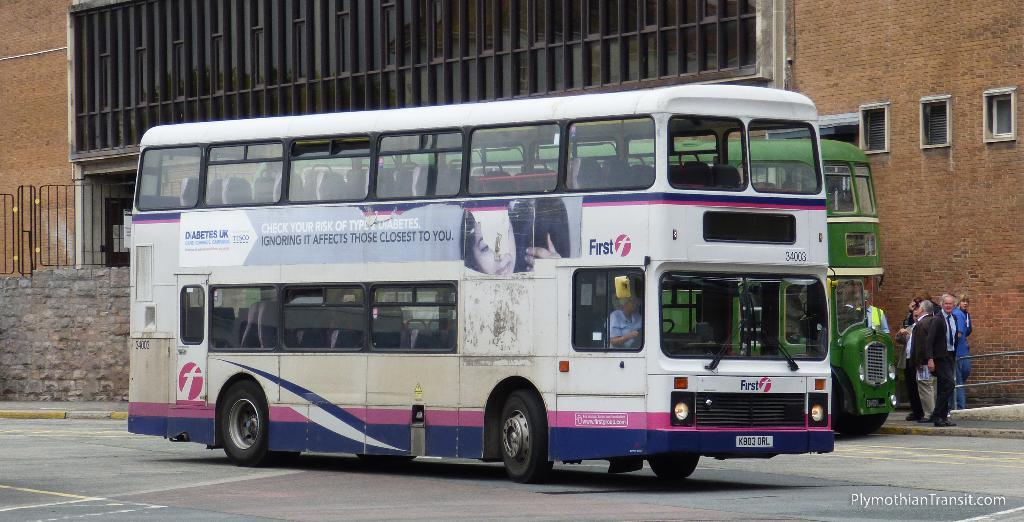<image>
Describe the image concisely. Double decker bus #34003 has an advertisement for Diabetes UK on the side. 